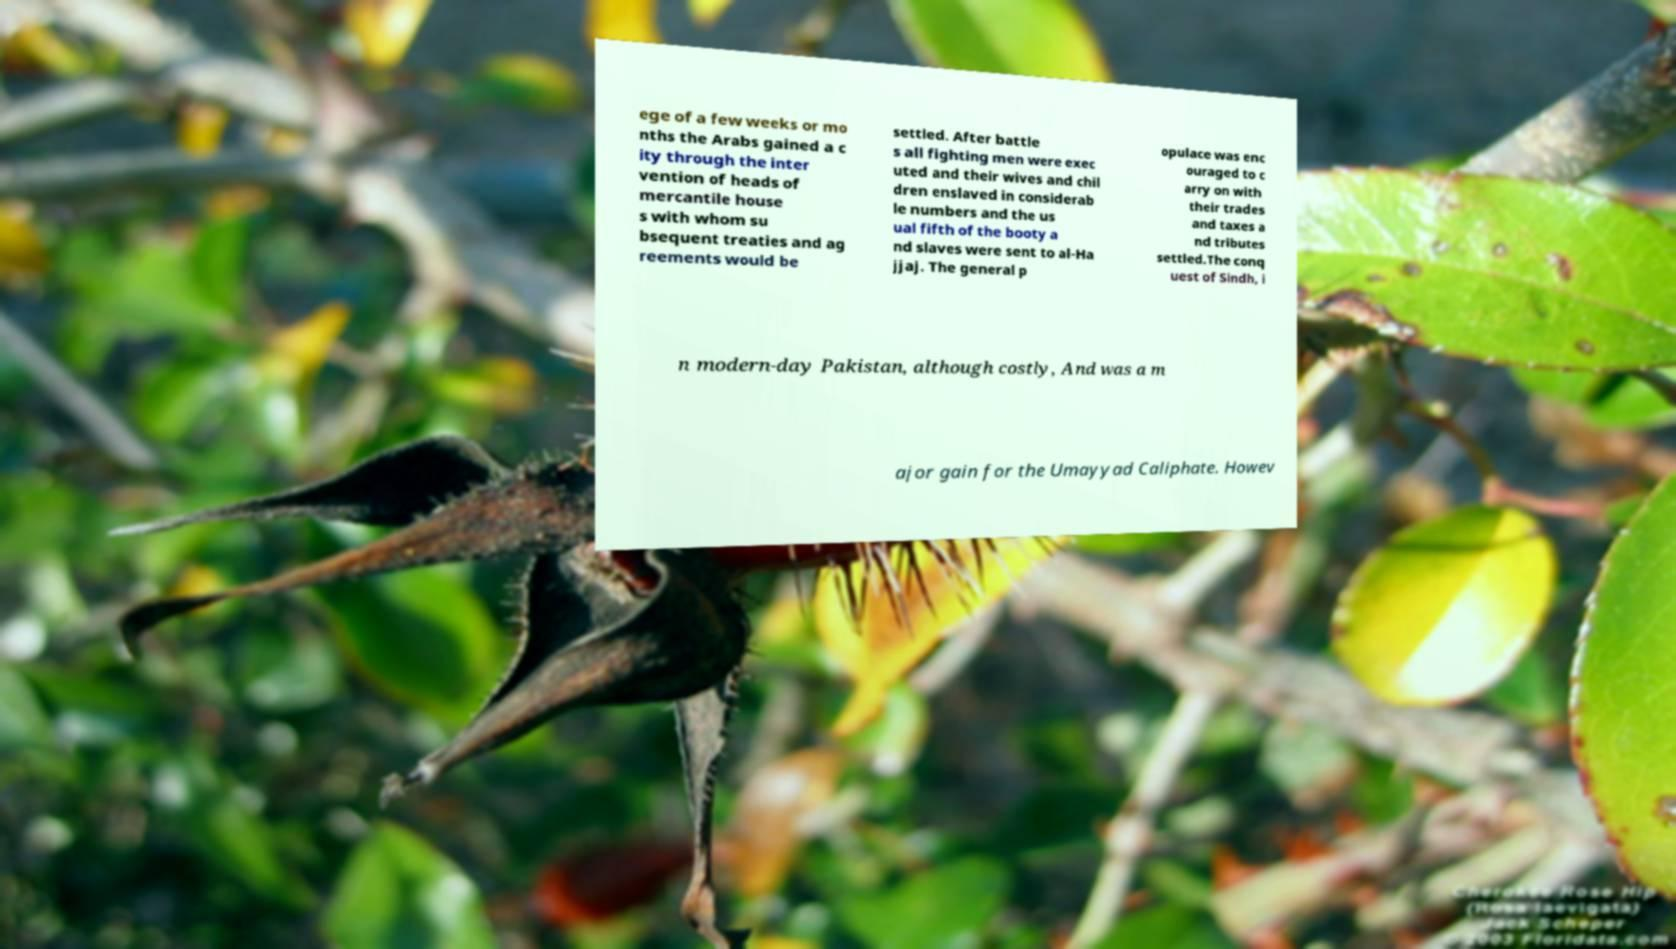Please read and relay the text visible in this image. What does it say? ege of a few weeks or mo nths the Arabs gained a c ity through the inter vention of heads of mercantile house s with whom su bsequent treaties and ag reements would be settled. After battle s all fighting men were exec uted and their wives and chil dren enslaved in considerab le numbers and the us ual fifth of the booty a nd slaves were sent to al-Ha jjaj. The general p opulace was enc ouraged to c arry on with their trades and taxes a nd tributes settled.The conq uest of Sindh, i n modern-day Pakistan, although costly, And was a m ajor gain for the Umayyad Caliphate. Howev 